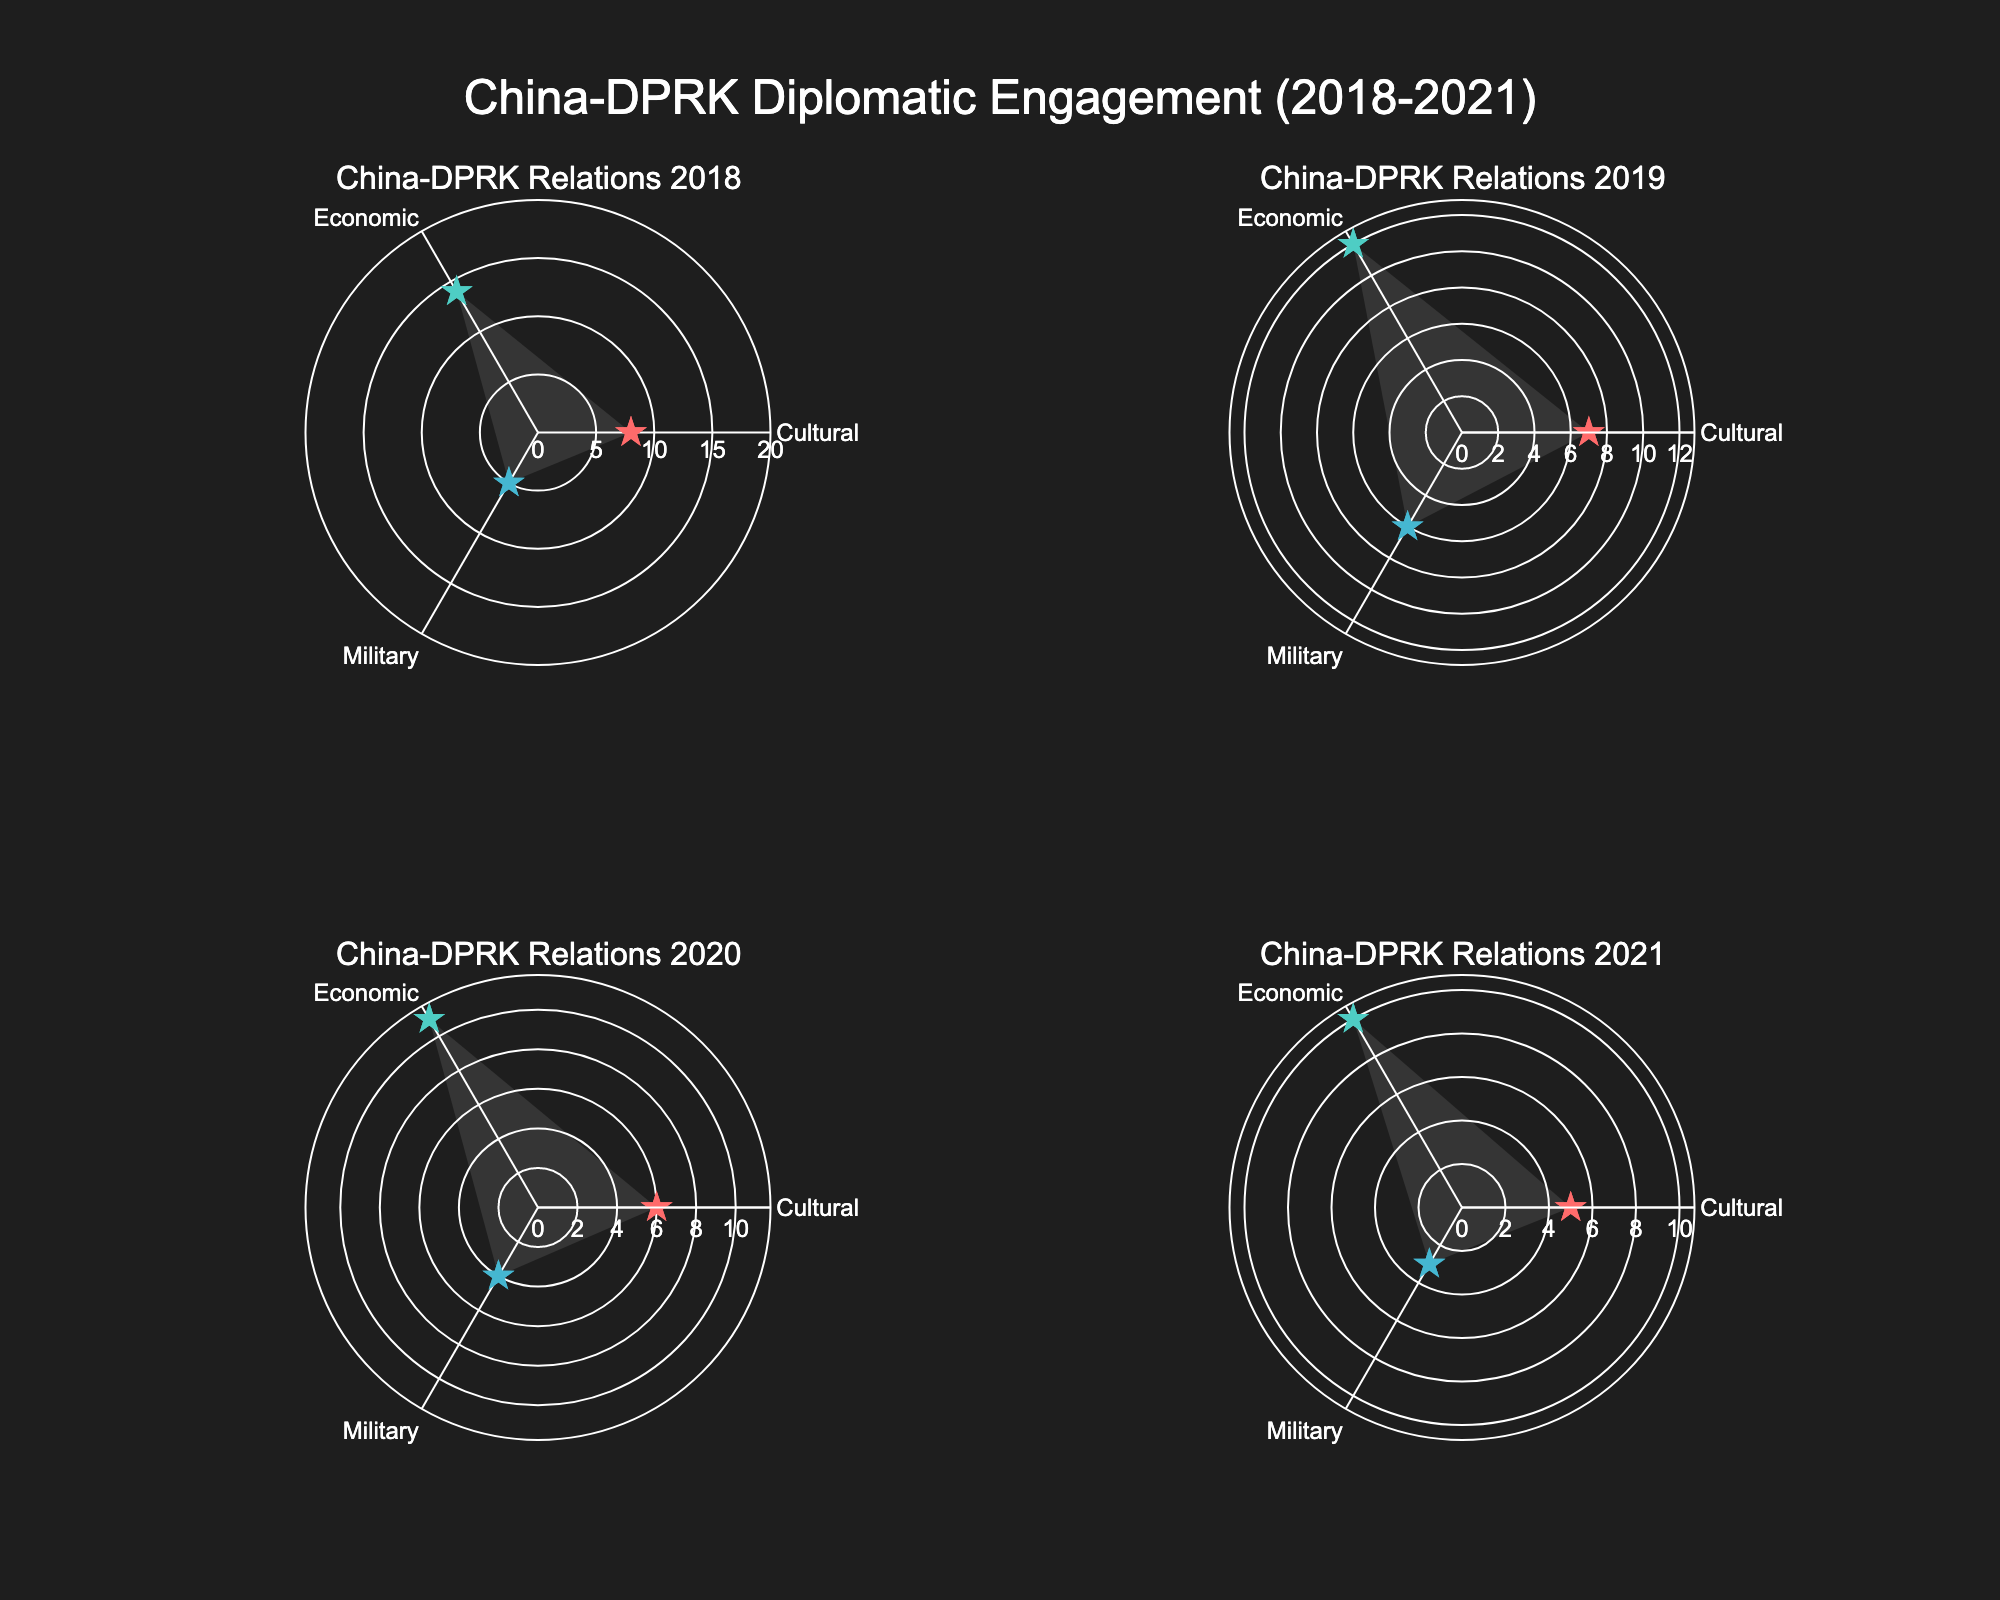what is the title of the overall plot? The title is located at the top center of the plot and it summarizes what the figure represents, highlighting the recent years covered.
Answer: China-DPRK Diplomatic Engagement (2018-2021) How many different types of diplomatic engagements are shown in each subplot? Each subplot shows the three types of diplomatic engagements, which are evident from the different categories displayed in the radial axis.
Answer: Three In 2020, what was the frequency of Economic engagements? By looking at the subplot for the year 2020, locate the 'Economic' category on the radial axis and read the corresponding value.
Answer: 11 Which year had the highest Cultural engagement frequency? By surveying each subplot, find the maximum value in the 'Cultural' category and identify the corresponding year.
Answer: 2018 What is the average Military engagement frequency over the years 2018, 2019, 2020, and 2021? Sum the Military engagement frequencies from these years (5 + 6 + 4 + 3) and then divide by 4 to find the average.
Answer: 4.5 Compare the Economic engagement frequencies between 2018 and 2019. Which year had a higher frequency and by how much? Locate the Economic engagement values for 2018 and 2019, then subtract the 2019 value from the 2018 value to find the difference.
Answer: 2018 by 2 Is there any year where the Military engagement was higher than Economic engagement? Comparing each year in the subplots, check if any Military engagement value is greater than the corresponding Economic engagement value.
Answer: No Which year had the lowest Military engagement frequency? Scan across each subplot's Military category to identify the lowest value and the corresponding year.
Answer: 2021 Are Cultural engagements consistently higher or lower than Military engagements from 2018 to 2021? By comparing the Cultural and Military engagement frequencies in each subplot from 2018 to 2021, observe if one category consistently has higher or lower values.
Answer: Higher Which diplomatic engagement type showed the least variation in frequency from 2018 to 2021? Calculate the range (max value - min value) of frequencies for each engagement type over the years and compare these ranges.
Answer: Military 